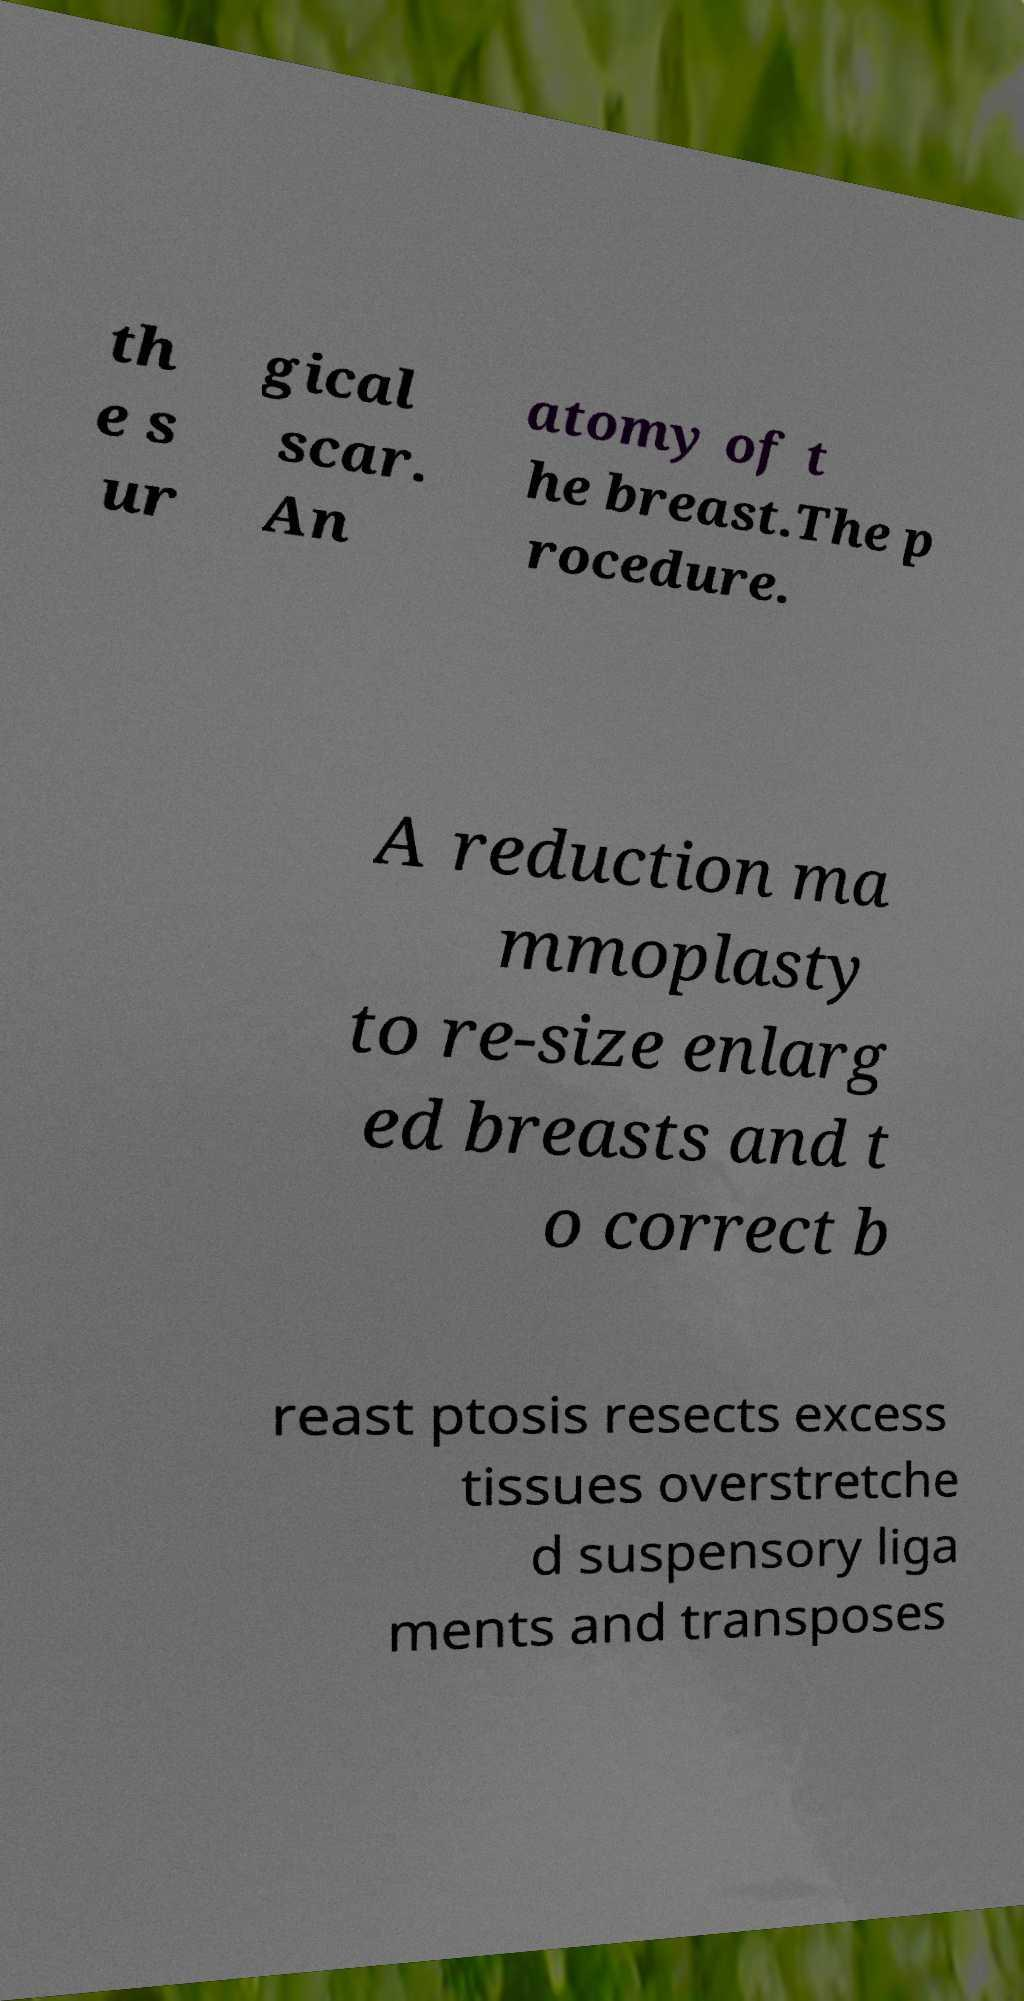Can you accurately transcribe the text from the provided image for me? th e s ur gical scar. An atomy of t he breast.The p rocedure. A reduction ma mmoplasty to re-size enlarg ed breasts and t o correct b reast ptosis resects excess tissues overstretche d suspensory liga ments and transposes 